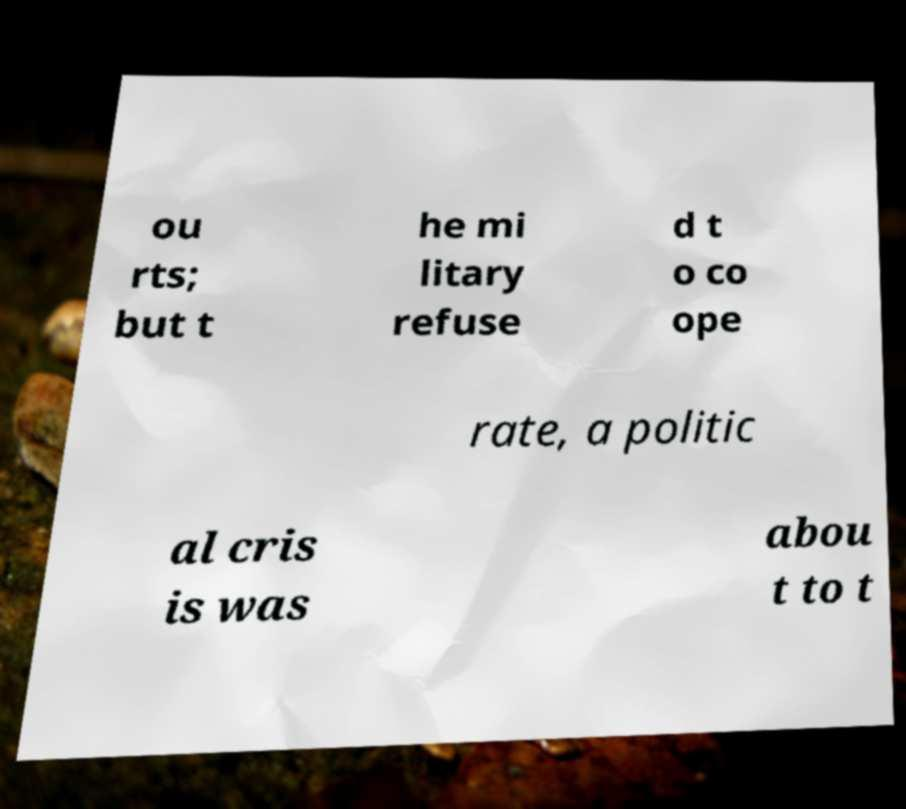Please identify and transcribe the text found in this image. ou rts; but t he mi litary refuse d t o co ope rate, a politic al cris is was abou t to t 